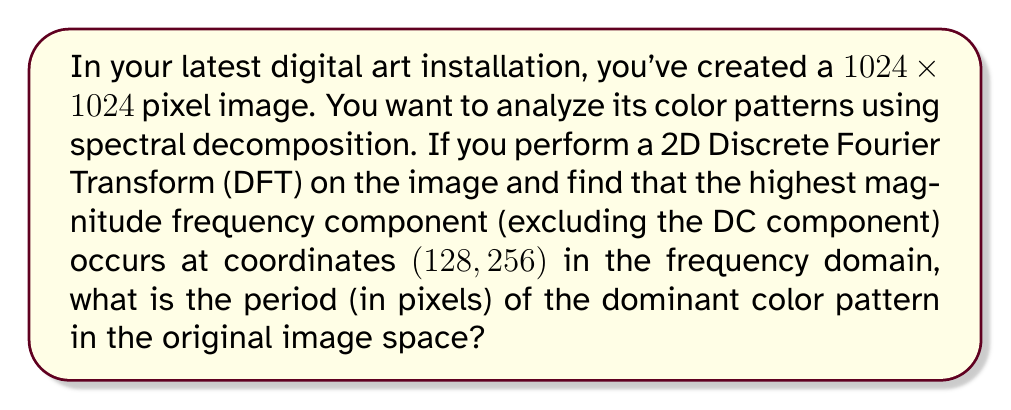What is the answer to this math problem? Let's approach this step-by-step:

1) The 2D DFT of an NxN image results in an NxN frequency domain representation. In this case, N = 1024.

2) In the frequency domain, the coordinates (u, v) represent spatial frequencies. The relationship between spatial frequency and image space is:

   $$ f_x = \frac{u}{N}, f_y = \frac{v}{N} $$

   where $f_x$ and $f_y$ are spatial frequencies in cycles per pixel.

3) Given coordinates (128, 256), we have:

   $$ f_x = \frac{128}{1024} = \frac{1}{8} \text{ cycles/pixel} $$
   $$ f_y = \frac{256}{1024} = \frac{1}{4} \text{ cycles/pixel} $$

4) The period is the inverse of frequency. So:

   $$ T_x = \frac{1}{f_x} = 8 \text{ pixels} $$
   $$ T_y = \frac{1}{f_y} = 4 \text{ pixels} $$

5) The dominant pattern will have a period that combines both x and y components. We can find this using the Pythagorean theorem:

   $$ T = \sqrt{T_x^2 + T_y^2} = \sqrt{8^2 + 4^2} = \sqrt{80} \approx 8.94 \text{ pixels} $$
Answer: $\sqrt{80}$ pixels (approximately 8.94 pixels) 